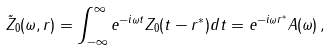<formula> <loc_0><loc_0><loc_500><loc_500>\tilde { Z } _ { 0 } ( \omega , r ) = \int _ { - \infty } ^ { \infty } e ^ { - i \omega t } Z _ { 0 } ( t - r ^ { * } ) d t = e ^ { - i \omega r ^ { * } } A ( \omega ) \, ,</formula> 